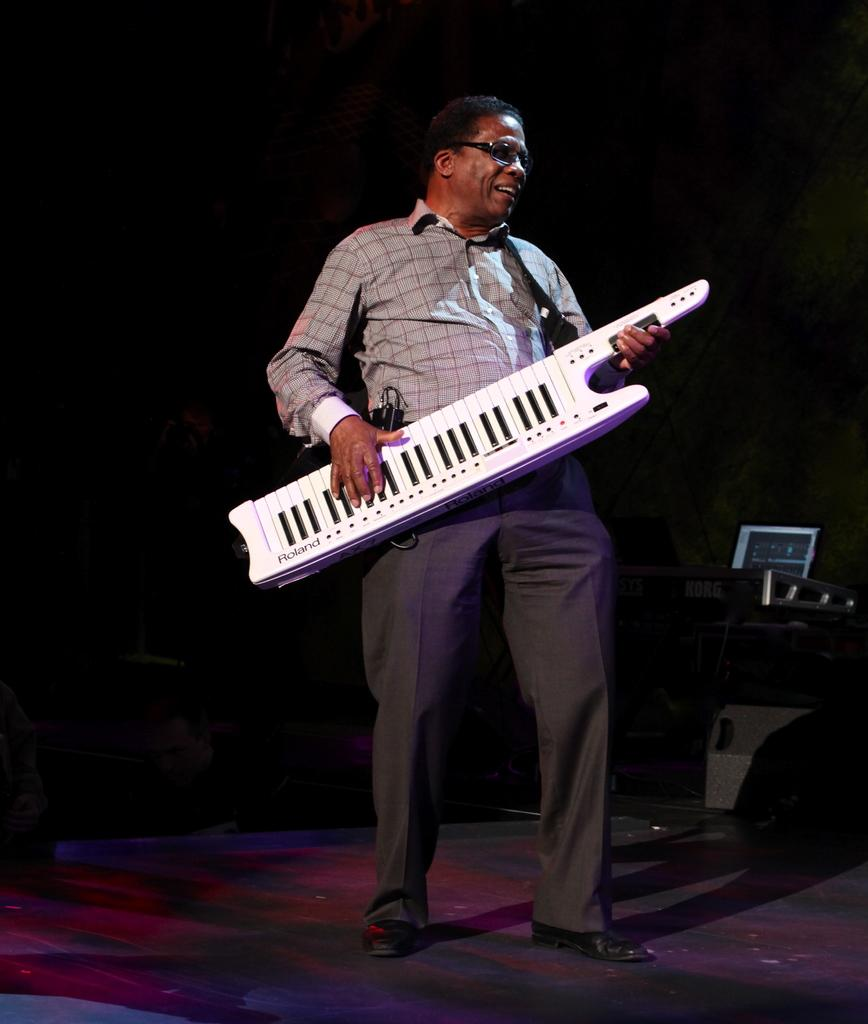Who is the main subject in the foreground of the image? There is a man in the foreground of the image. What is the man doing in the image? The man is standing and playing a keytar. What can be observed about the background of the image? The background of the image is dark. Are there any baby animals visible in the image? There are no baby animals present in the image. Can you see any cobwebs in the image? There is no mention of cobwebs in the image, and they are not visible in the provided facts. 